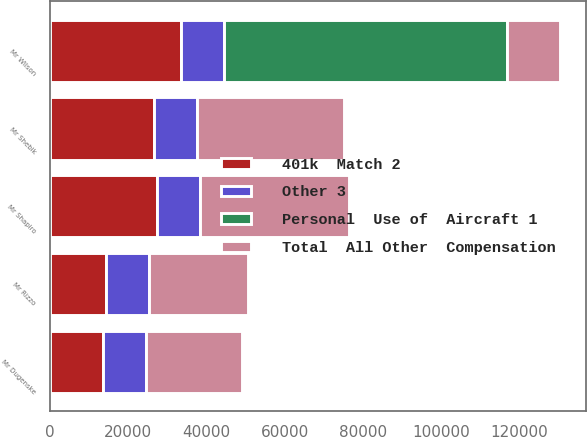Convert chart to OTSL. <chart><loc_0><loc_0><loc_500><loc_500><stacked_bar_chart><ecel><fcel>Mr Wilson<fcel>Mr Rizzo<fcel>Mr Dugenske<fcel>Mr Shapiro<fcel>Mr Shebik<nl><fcel>Personal  Use of  Aircraft 1<fcel>72331<fcel>0<fcel>0<fcel>0<fcel>0<nl><fcel>Other 3<fcel>11000<fcel>11000<fcel>11000<fcel>11000<fcel>11000<nl><fcel>401k  Match 2<fcel>33640<fcel>14391<fcel>13560<fcel>27270<fcel>26560<nl><fcel>Total  All Other  Compensation<fcel>13560<fcel>25391<fcel>24560<fcel>38270<fcel>37560<nl></chart> 